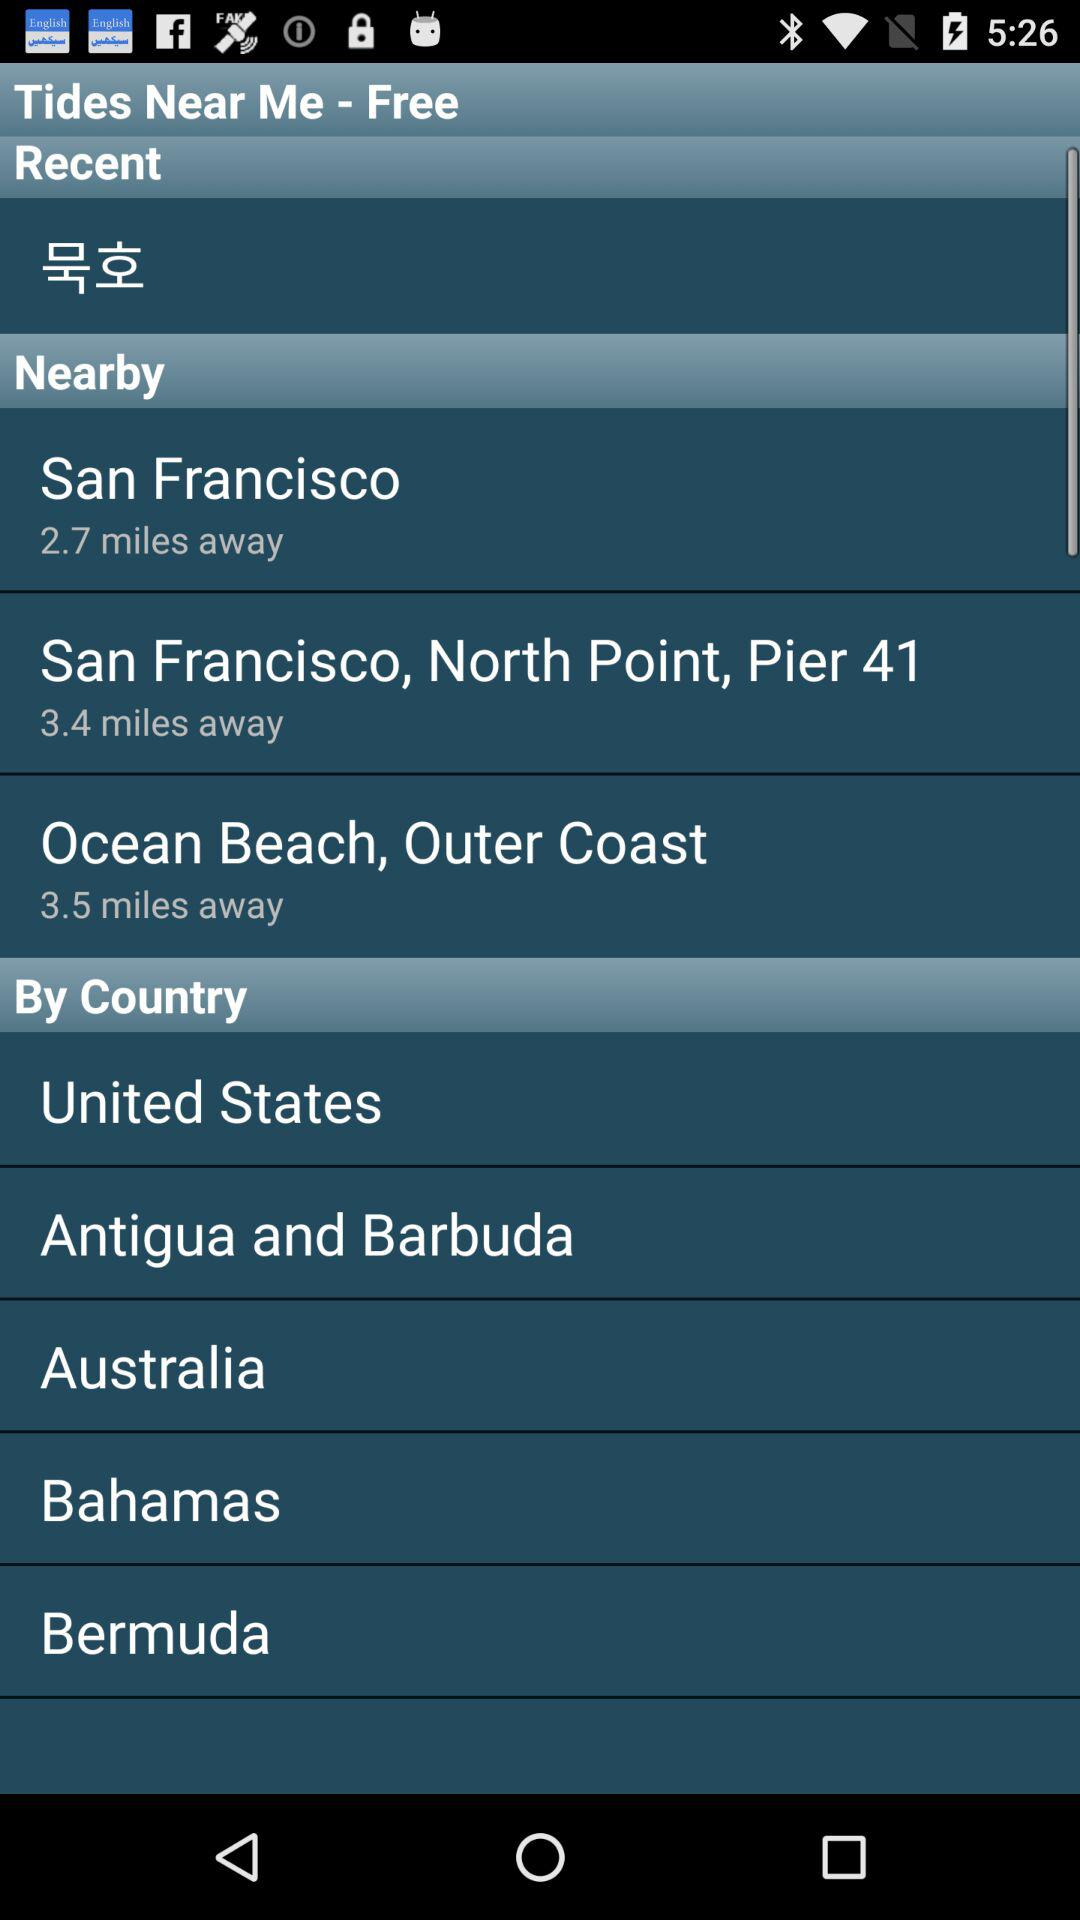What are the available countries? The available countries are the United States, Antigua and Barbuda, Australia, the Bahamas and Bermuda. 